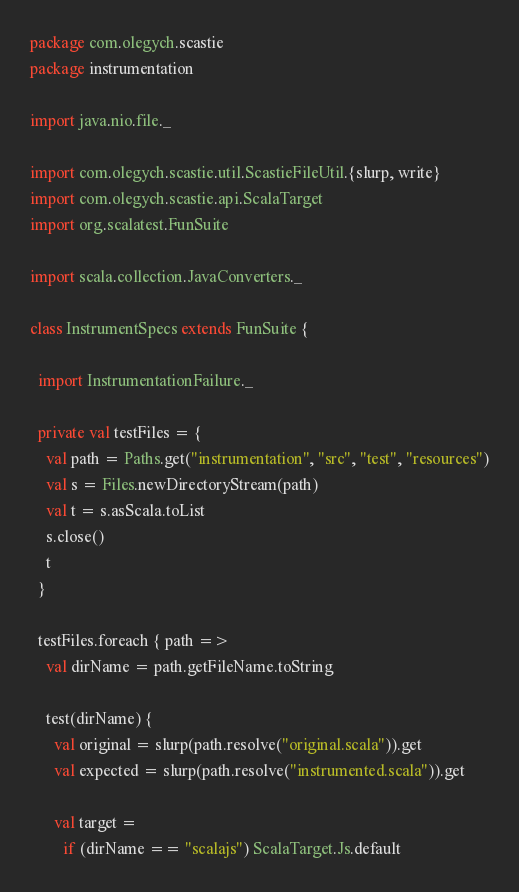Convert code to text. <code><loc_0><loc_0><loc_500><loc_500><_Scala_>package com.olegych.scastie
package instrumentation

import java.nio.file._

import com.olegych.scastie.util.ScastieFileUtil.{slurp, write}
import com.olegych.scastie.api.ScalaTarget
import org.scalatest.FunSuite

import scala.collection.JavaConverters._

class InstrumentSpecs extends FunSuite {

  import InstrumentationFailure._

  private val testFiles = {
    val path = Paths.get("instrumentation", "src", "test", "resources")
    val s = Files.newDirectoryStream(path)
    val t = s.asScala.toList
    s.close()
    t
  }

  testFiles.foreach { path =>
    val dirName = path.getFileName.toString

    test(dirName) {
      val original = slurp(path.resolve("original.scala")).get
      val expected = slurp(path.resolve("instrumented.scala")).get

      val target =
        if (dirName == "scalajs") ScalaTarget.Js.default</code> 